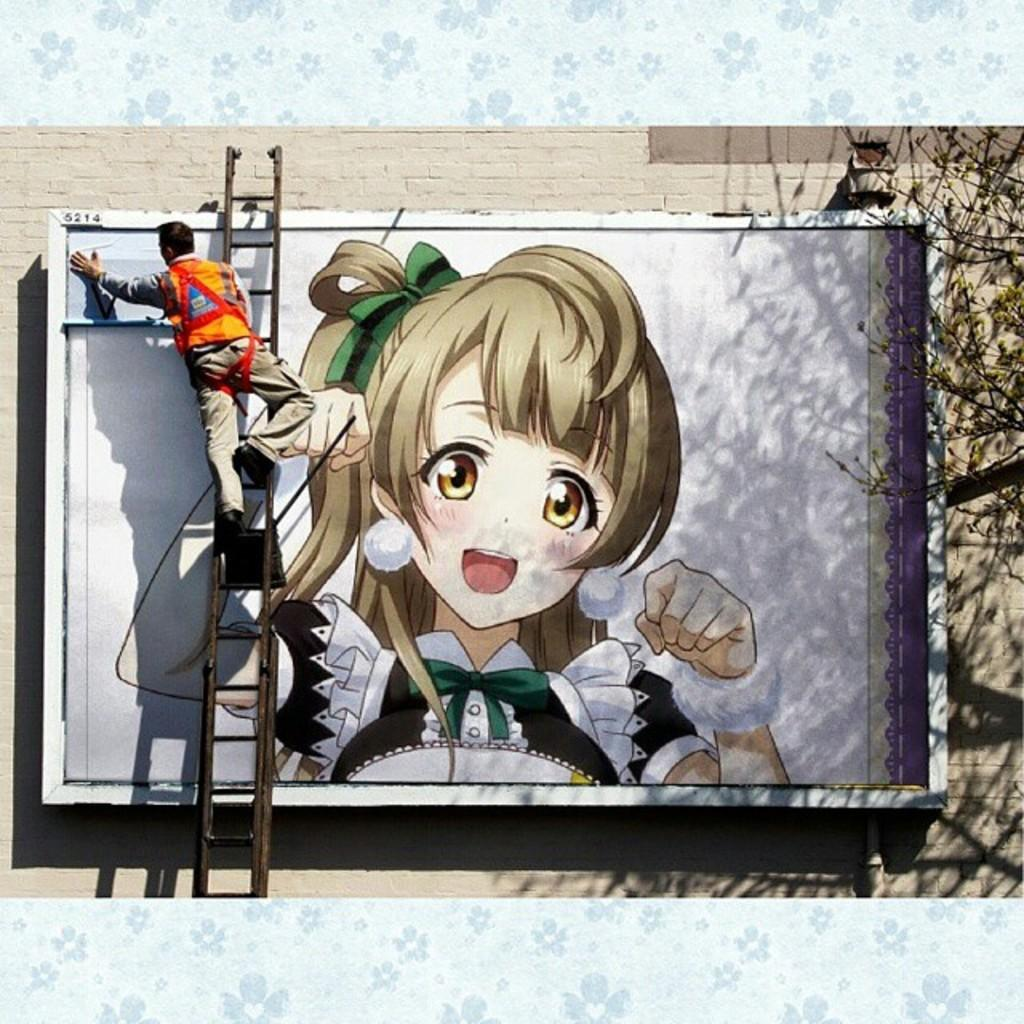Who is present in the image? There is a man in the image. What is the man doing in the image? The man is standing on a ladder and painting. What can be seen in the background of the image? There is an art of a girl in the image. Where is the toad located in the image? There is no toad present in the image. What type of zipper can be seen on the man's clothing in the image? There is no zipper visible on the man's clothing in the image. 